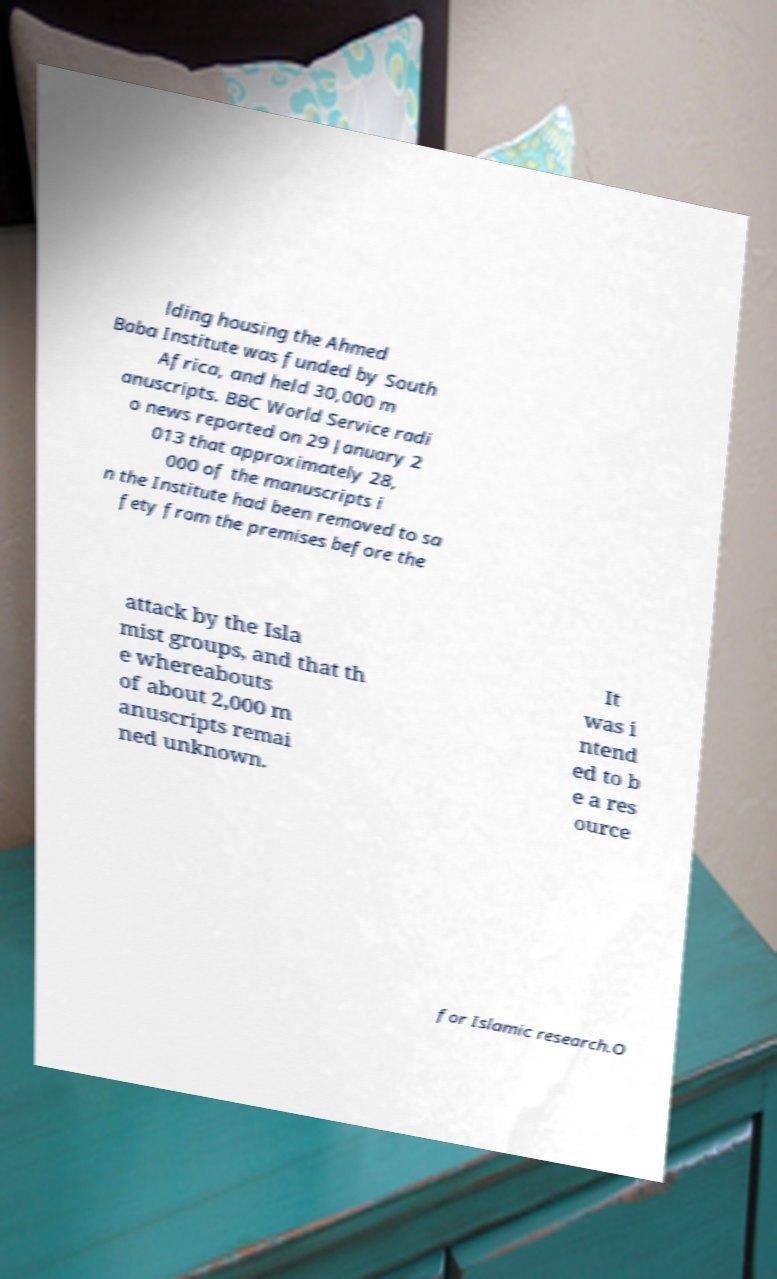Can you read and provide the text displayed in the image?This photo seems to have some interesting text. Can you extract and type it out for me? lding housing the Ahmed Baba Institute was funded by South Africa, and held 30,000 m anuscripts. BBC World Service radi o news reported on 29 January 2 013 that approximately 28, 000 of the manuscripts i n the Institute had been removed to sa fety from the premises before the attack by the Isla mist groups, and that th e whereabouts of about 2,000 m anuscripts remai ned unknown. It was i ntend ed to b e a res ource for Islamic research.O 